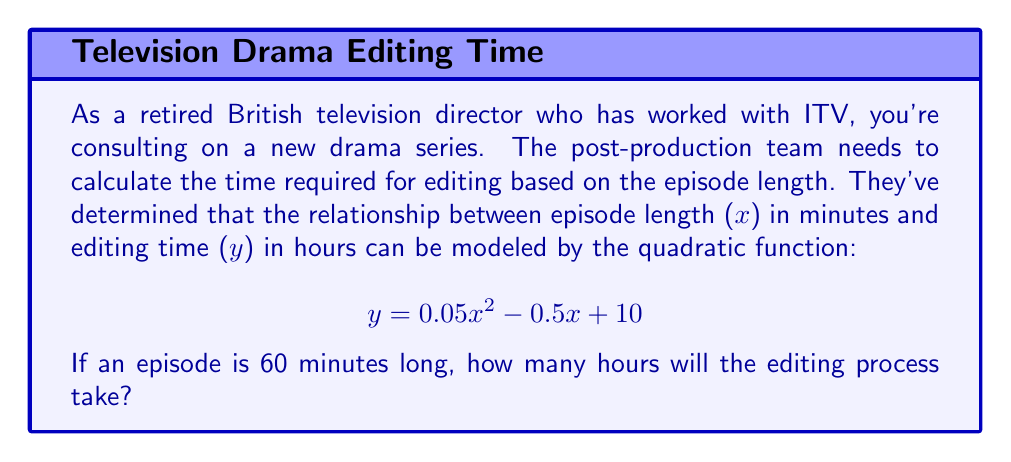Could you help me with this problem? To solve this problem, we need to substitute the episode length (x = 60) into the given quadratic function:

$$y = 0.05x^2 - 0.5x + 10$$

Let's substitute x = 60:

$$\begin{align*}
y &= 0.05(60)^2 - 0.5(60) + 10 \\
&= 0.05(3600) - 30 + 10 \\
&= 180 - 30 + 10 \\
&= 160
\end{align*}$$

Therefore, the editing process for a 60-minute episode will take 160 hours.

This quadratic function reflects the non-linear relationship between episode length and editing time. As episodes get longer, the editing time increases at a faster rate due to the complexity of managing more footage and maintaining continuity over a longer duration.
Answer: 160 hours 